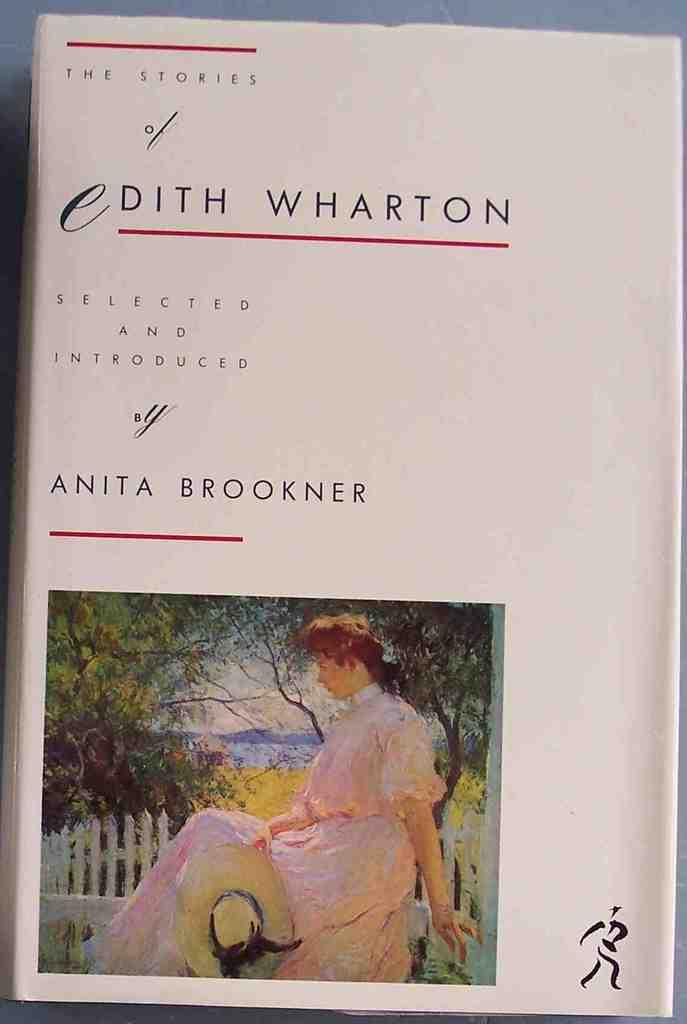What is the main object in the image? There is a book in the image. What can be seen on the book? The book has edited text on it and a picture of a woman. What is the woman doing in the picture on the book? The woman is sitting on a wooden fence. What type of vegetation is visible in the image? There are trees visible in the image. What else can be seen in the image besides the book? There is a logo in the image. How much honey is being consumed by the woman in the image? There is no honey present in the image, and the woman is only depicted in the picture on the book. 